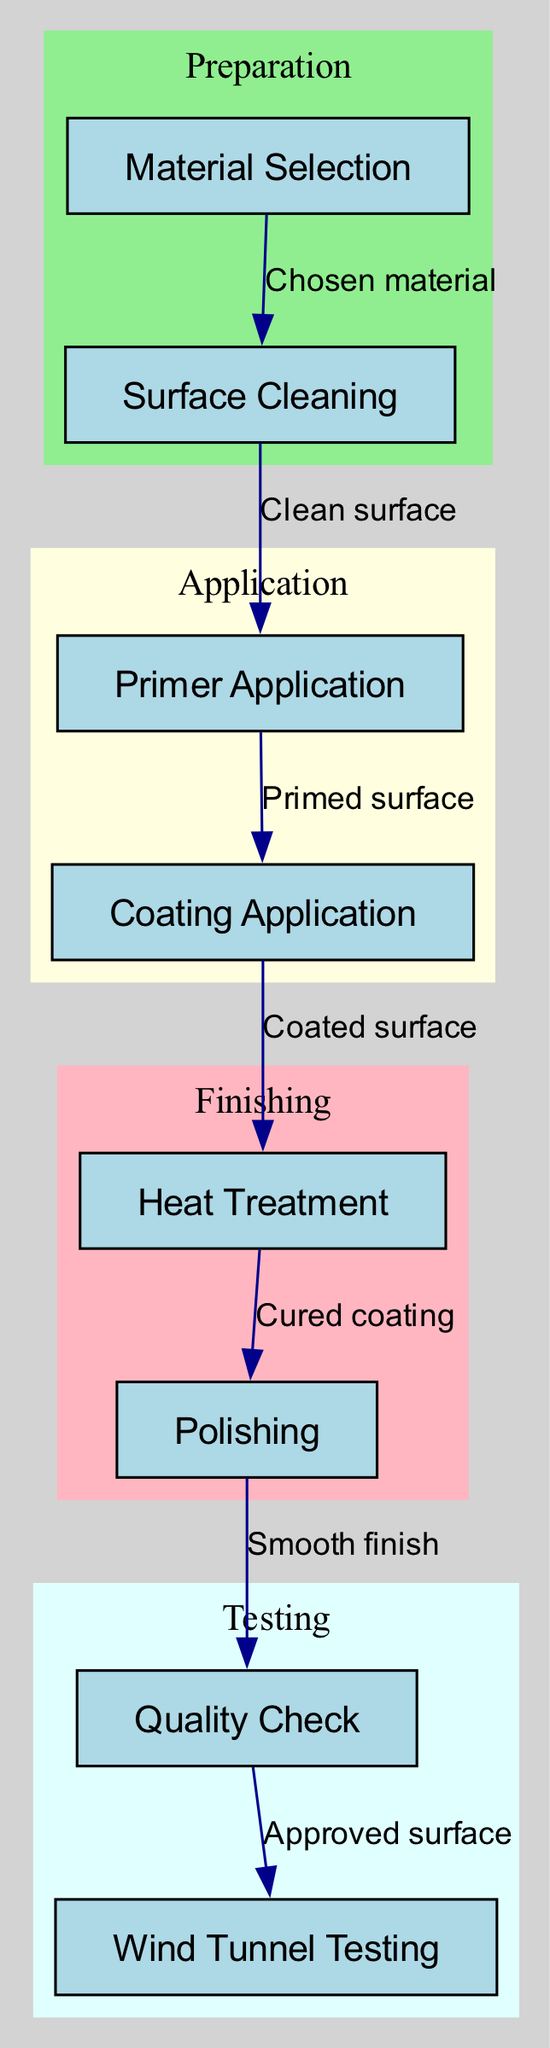What is the starting node of the flow chart? The flow chart starts with the node labeled "Material Selection." This can be determined by reviewing the edges, as there are no incoming edges to this node, indicating it is the initial step in the process.
Answer: Material Selection How many nodes are present in the flow chart? By counting the nodes listed in the diagram, we find there are eight unique steps in the process: Material Selection, Surface Cleaning, Primer Application, Coating Application, Heat Treatment, Polishing, Quality Check, and Wind Tunnel Testing.
Answer: 8 Which step follows the Surface Cleaning stage? The flow chart indicates that after Surface Cleaning, the next step is Primer Application. This can be validated by tracing the edge that leads from Surface Cleaning to Primer Application.
Answer: Primer Application What process follows Quality Check? The diagram shows that the process after Quality Check is Wind Tunnel Testing, as indicated by the directed flow from Quality Check to Wind Tunnel Testing.
Answer: Wind Tunnel Testing What is the relationship between Primer Application and Coating Application? Primer Application leads to Coating Application, as shown by the directed edge labeled "Primed surface." This indicates that after Primer Application, the surface must be coated to proceed in the process.
Answer: Primed surface How many edges are there connecting different nodes? By examining the connections in the diagram, we find there are seven directed edges that connect the nodes, indicating the flow of the process from one step to the next.
Answer: 7 Which node represents the finishing stage of the process? In the diagram, the nodes labeled "Heat Treatment" and "Polishing" are grouped in the subgraph labeled "Finishing." This identifies them as the finishing stages of the overall treatment process.
Answer: Heat Treatment, Polishing What is the last stage of the process? The last node in the flow chart is Wind Tunnel Testing, which follows Quality Check. This indicates that after quality verification, the product is finally tested in a wind tunnel.
Answer: Wind Tunnel Testing Which two steps come before the Polishing stage? According to the flow chart, the two steps that precede Polishing are Heat Treatment and Coating Application. Heat Treatment directly follows Coating Application, and both steps are required to reach Polishing.
Answer: Heat Treatment, Coating Application 